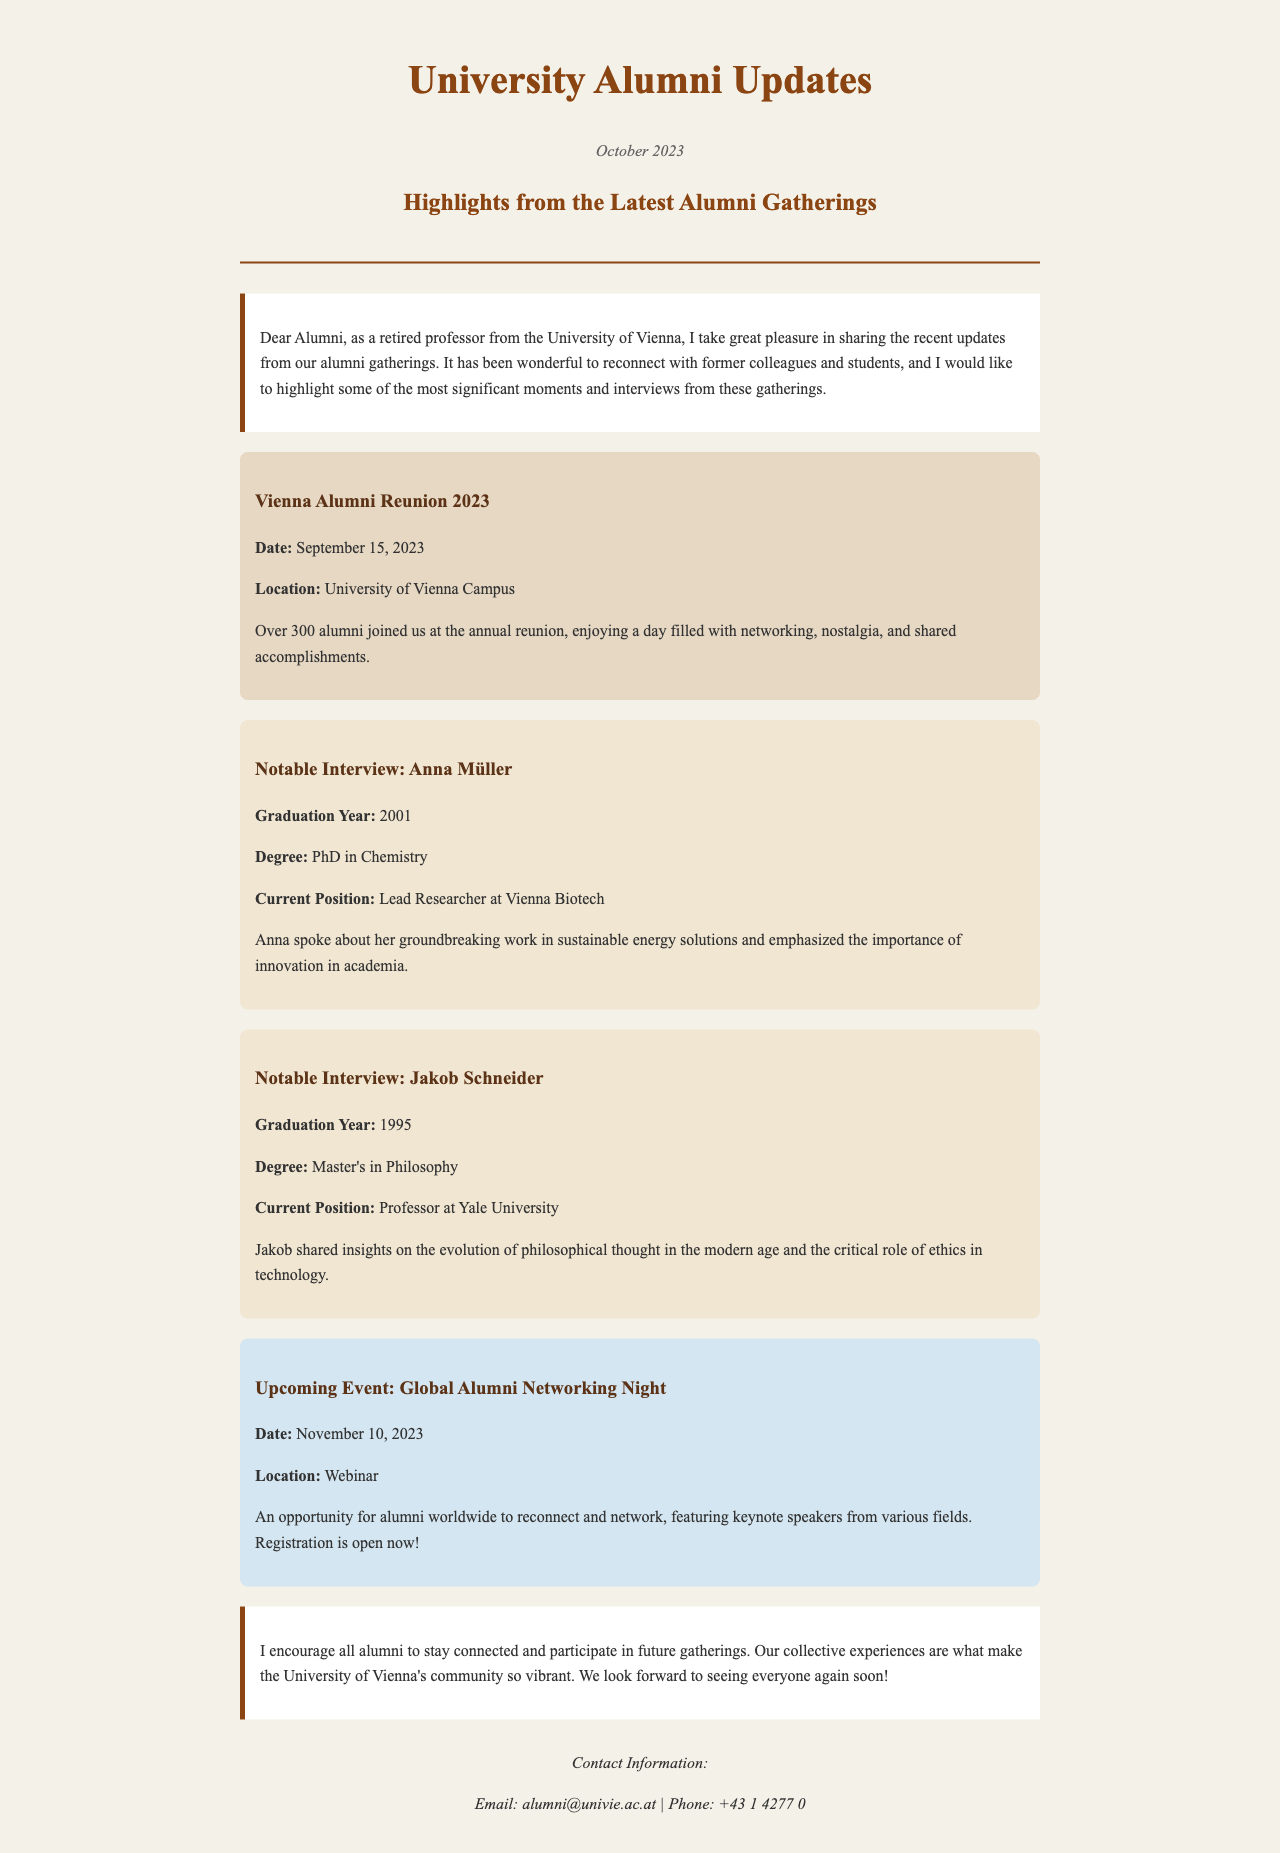What was the date of the Vienna Alumni Reunion 2023? The document states the Vienna Alumni Reunion took place on September 15, 2023.
Answer: September 15, 2023 Who was interviewed in the newsletter? The document lists Anna Müller and Jakob Schneider as notable interviewees.
Answer: Anna Müller, Jakob Schneider What is Anna Müller's current position? The document states that Anna Müller is the Lead Researcher at Vienna Biotech.
Answer: Lead Researcher at Vienna Biotech What is the theme of Jakob Schneider's insights? The document mentions that Jakob Schneider shared insights on the evolution of philosophical thought and ethics in technology.
Answer: Evolution of philosophical thought, ethics in technology When is the upcoming Global Alumni Networking Night? The document specifies that the upcoming event is scheduled for November 10, 2023.
Answer: November 10, 2023 What degree did Jakob Schneider earn? The document indicates that Jakob Schneider earned a Master's in Philosophy.
Answer: Master's in Philosophy What was the main activity at the Vienna Alumni Reunion? The document describes the reunion as a day filled with networking, nostalgia, and shared accomplishments.
Answer: Networking, nostalgia, shared accomplishments What is the registration status for the upcoming event? The document states that registration for the Global Alumni Networking Night is open now.
Answer: Registration is open now 